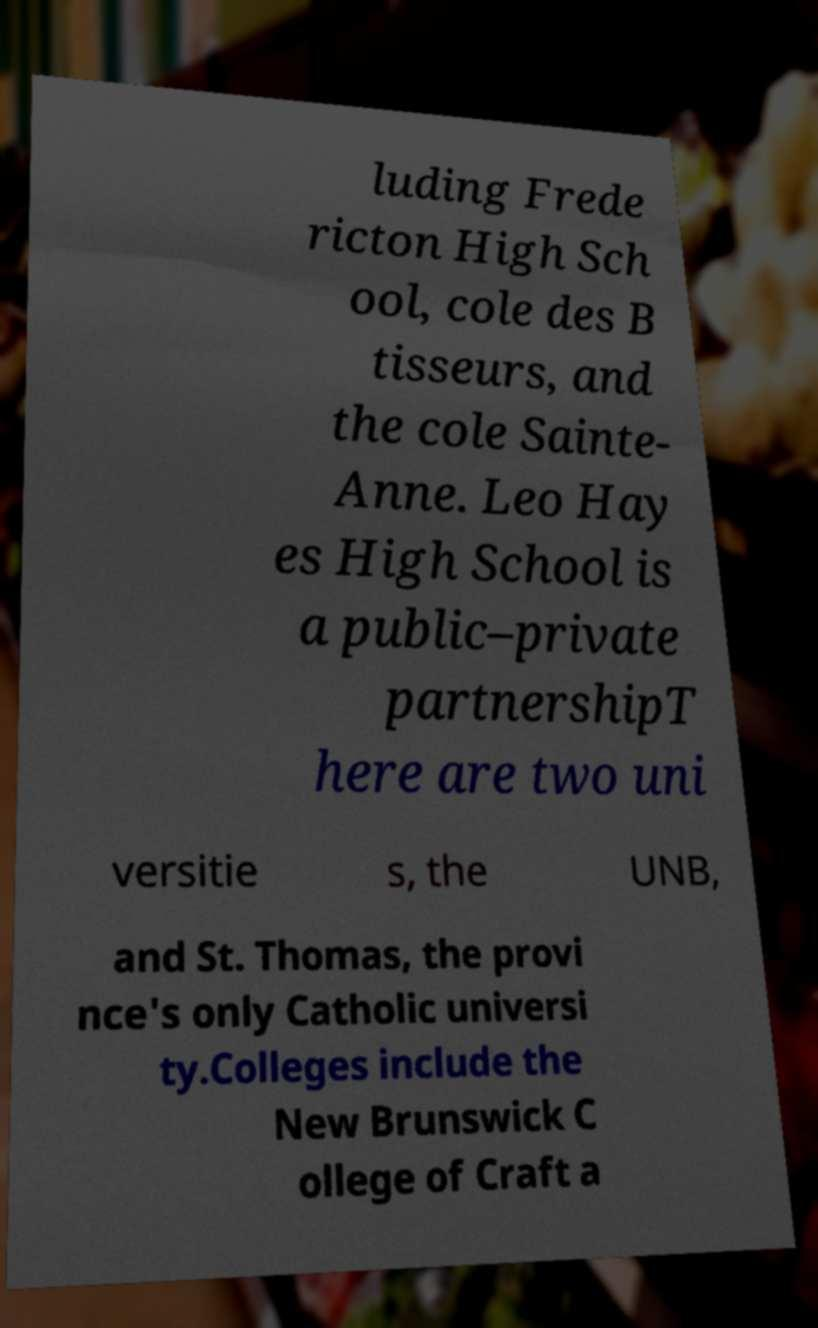I need the written content from this picture converted into text. Can you do that? luding Frede ricton High Sch ool, cole des B tisseurs, and the cole Sainte- Anne. Leo Hay es High School is a public–private partnershipT here are two uni versitie s, the UNB, and St. Thomas, the provi nce's only Catholic universi ty.Colleges include the New Brunswick C ollege of Craft a 